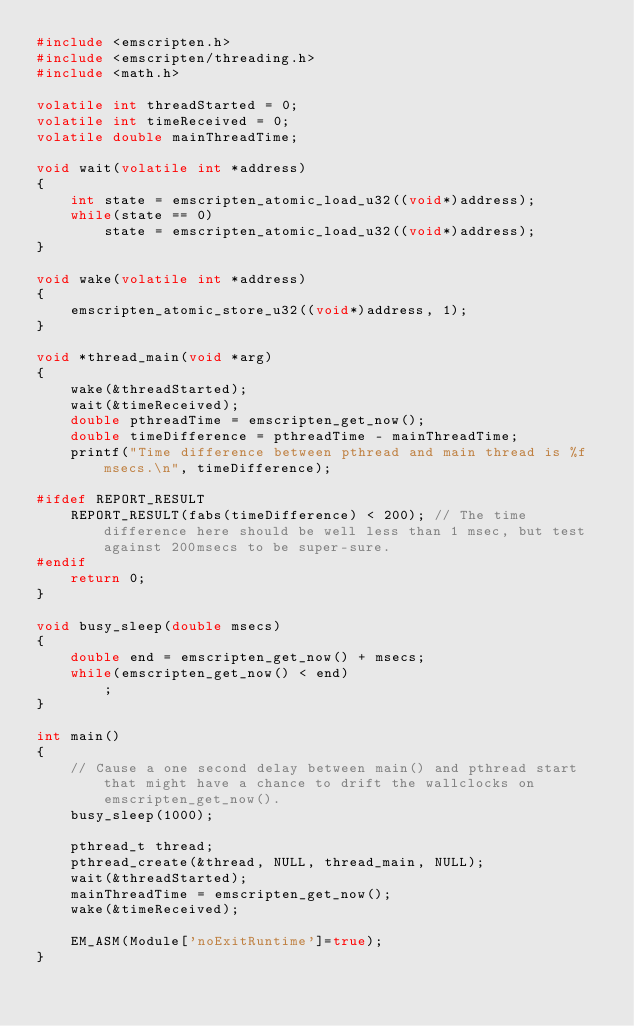Convert code to text. <code><loc_0><loc_0><loc_500><loc_500><_C++_>#include <emscripten.h>
#include <emscripten/threading.h>
#include <math.h>

volatile int threadStarted = 0;
volatile int timeReceived = 0;
volatile double mainThreadTime;

void wait(volatile int *address)
{
	int state = emscripten_atomic_load_u32((void*)address);
	while(state == 0)
		state = emscripten_atomic_load_u32((void*)address);
}

void wake(volatile int *address)
{
	emscripten_atomic_store_u32((void*)address, 1);
}

void *thread_main(void *arg)
{
	wake(&threadStarted);
	wait(&timeReceived);
	double pthreadTime = emscripten_get_now();
	double timeDifference = pthreadTime - mainThreadTime;
	printf("Time difference between pthread and main thread is %f msecs.\n", timeDifference);

#ifdef REPORT_RESULT
	REPORT_RESULT(fabs(timeDifference) < 200); // The time difference here should be well less than 1 msec, but test against 200msecs to be super-sure.
#endif
	return 0;
}

void busy_sleep(double msecs)
{
	double end = emscripten_get_now() + msecs;
	while(emscripten_get_now() < end)
		;
}

int main()
{
	// Cause a one second delay between main() and pthread start that might have a chance to drift the wallclocks on emscripten_get_now().
	busy_sleep(1000);

	pthread_t thread;
	pthread_create(&thread, NULL, thread_main, NULL);
	wait(&threadStarted);
	mainThreadTime = emscripten_get_now();
	wake(&timeReceived);

	EM_ASM(Module['noExitRuntime']=true);
}
</code> 